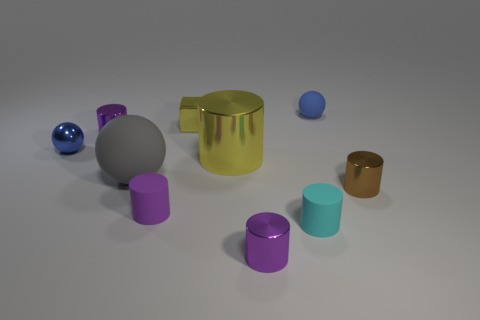Subtract all gray cubes. How many purple cylinders are left? 3 Subtract all tiny brown cylinders. How many cylinders are left? 5 Subtract all yellow cylinders. How many cylinders are left? 5 Subtract all brown cylinders. Subtract all brown blocks. How many cylinders are left? 5 Subtract all cubes. How many objects are left? 9 Subtract 0 green cylinders. How many objects are left? 10 Subtract all gray rubber things. Subtract all big blue rubber things. How many objects are left? 9 Add 2 small brown cylinders. How many small brown cylinders are left? 3 Add 3 big objects. How many big objects exist? 5 